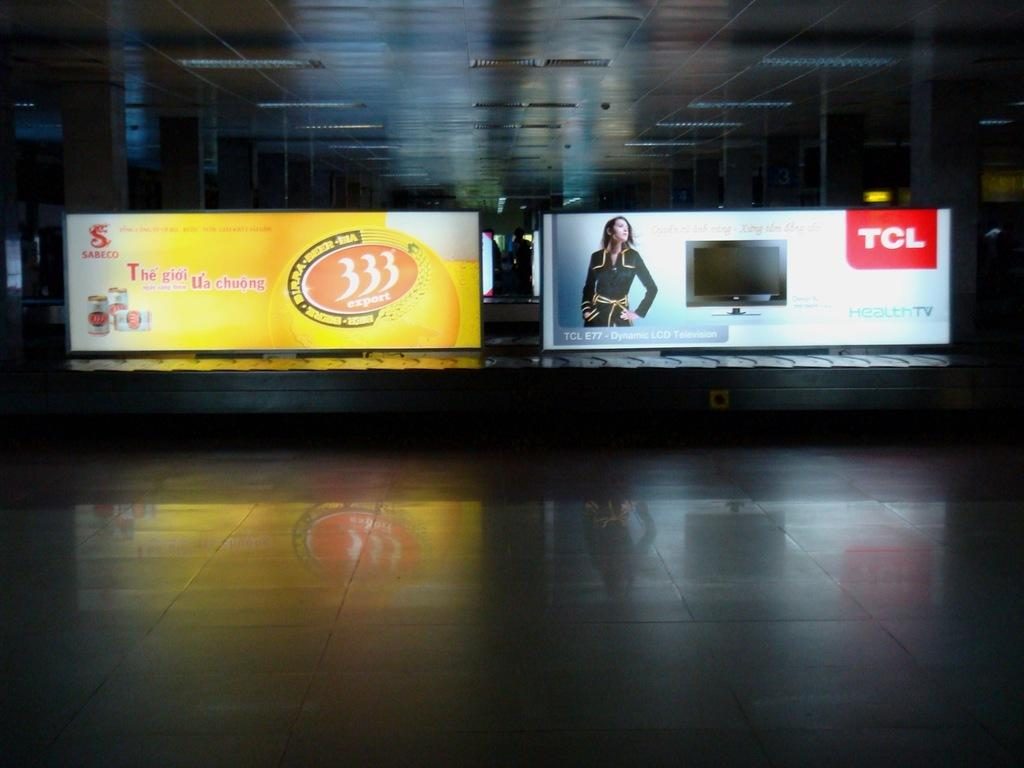<image>
Present a compact description of the photo's key features. two billboards with the name tcl on it 